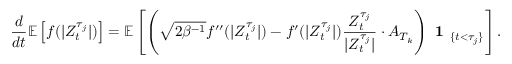Convert formula to latex. <formula><loc_0><loc_0><loc_500><loc_500>\frac { d } { d t } \mathbb { E } \left [ f ( | Z _ { t } ^ { \tau _ { j } } | ) \right ] = \mathbb { E } \left [ \left ( \sqrt { 2 \beta ^ { - 1 } } f ^ { \prime \prime } ( | Z _ { t } ^ { \tau _ { j } } | ) - f ^ { \prime } ( | Z _ { t } ^ { \tau _ { j } } | ) \frac { Z _ { t } ^ { \tau _ { j } } } { | Z _ { t } ^ { \tau _ { j } } | } \cdot A _ { T _ { k } } \right ) 1 _ { \{ t < \tau _ { j } \} } \right ] .</formula> 